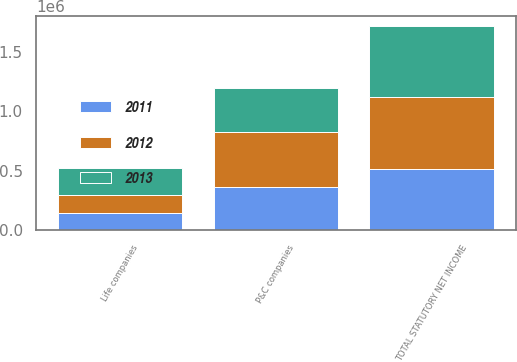Convert chart to OTSL. <chart><loc_0><loc_0><loc_500><loc_500><stacked_bar_chart><ecel><fcel>P&C companies<fcel>Life companies<fcel>TOTAL STATUTORY NET INCOME<nl><fcel>2012<fcel>457068<fcel>148851<fcel>605919<nl><fcel>2013<fcel>371520<fcel>223519<fcel>595039<nl><fcel>2011<fcel>367315<fcel>148554<fcel>515869<nl></chart> 